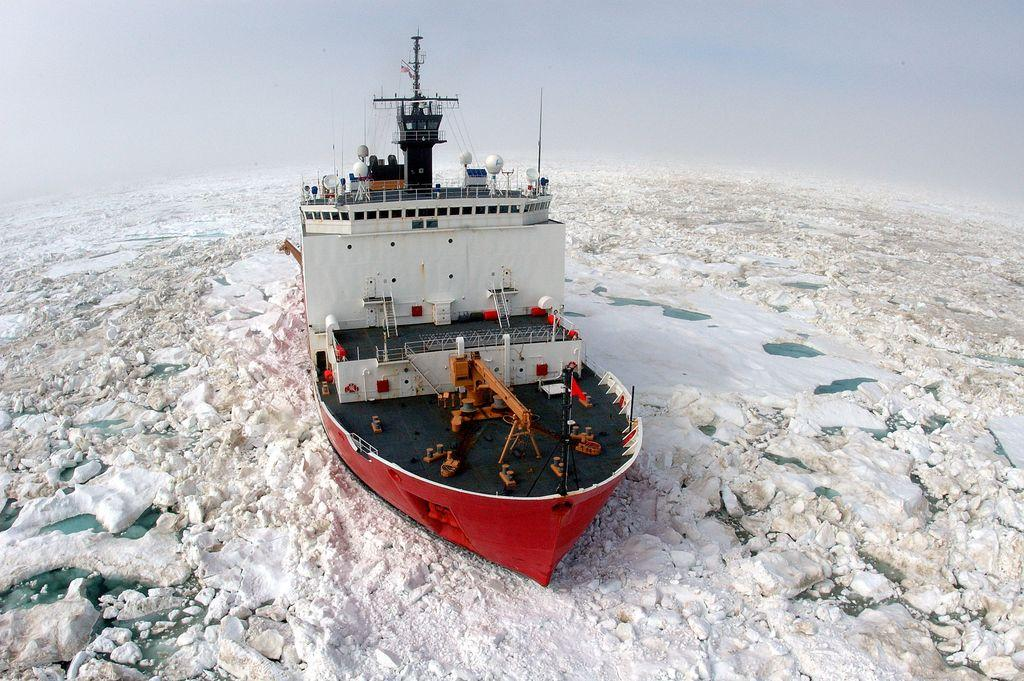What is the main subject of the image? The main subject of the image is a ship. What can be seen on the ship? The ship has a flag, a machine, railings, rods, and ladders. What is the ship floating on in the image? The ship is floating on water visible in the image. What is the unusual feature in the water? There is ice visible in the image. What is the color of the background in the image? The background of the image is white. Can you hear the ship's engine in the image? There is no mention of an engine in the image. 